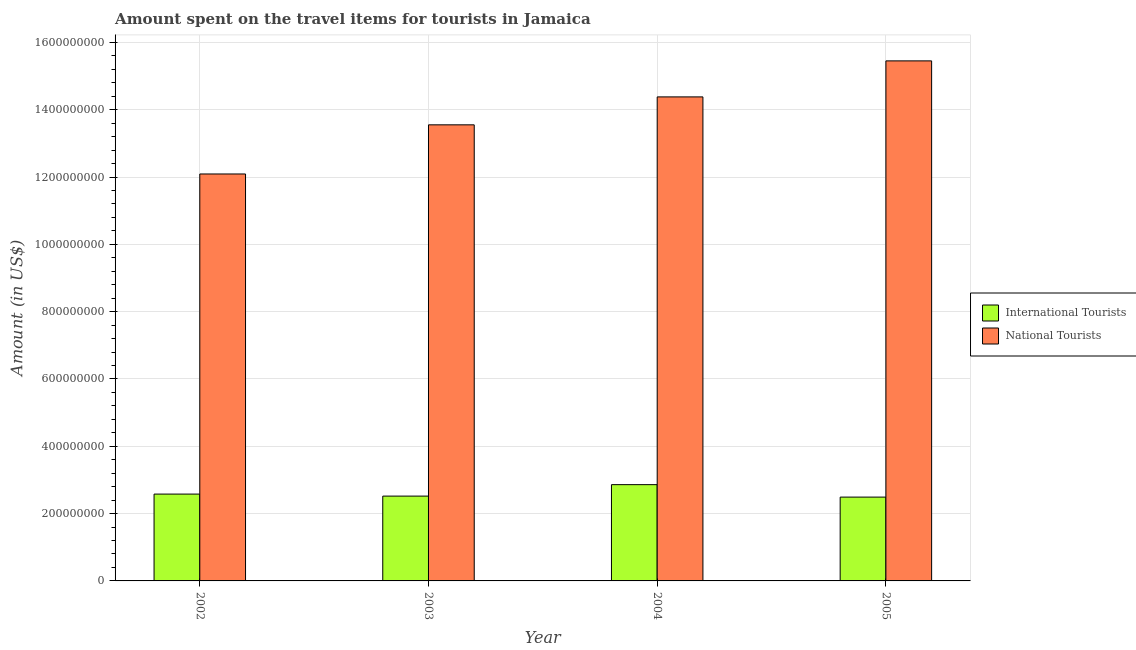How many different coloured bars are there?
Make the answer very short. 2. Are the number of bars on each tick of the X-axis equal?
Provide a short and direct response. Yes. How many bars are there on the 2nd tick from the right?
Ensure brevity in your answer.  2. What is the label of the 1st group of bars from the left?
Give a very brief answer. 2002. In how many cases, is the number of bars for a given year not equal to the number of legend labels?
Your response must be concise. 0. What is the amount spent on travel items of international tourists in 2003?
Offer a terse response. 2.52e+08. Across all years, what is the maximum amount spent on travel items of international tourists?
Provide a short and direct response. 2.86e+08. Across all years, what is the minimum amount spent on travel items of national tourists?
Offer a terse response. 1.21e+09. In which year was the amount spent on travel items of international tourists maximum?
Ensure brevity in your answer.  2004. What is the total amount spent on travel items of international tourists in the graph?
Keep it short and to the point. 1.04e+09. What is the difference between the amount spent on travel items of international tourists in 2002 and that in 2005?
Make the answer very short. 9.00e+06. What is the difference between the amount spent on travel items of international tourists in 2005 and the amount spent on travel items of national tourists in 2004?
Provide a short and direct response. -3.70e+07. What is the average amount spent on travel items of national tourists per year?
Offer a terse response. 1.39e+09. What is the ratio of the amount spent on travel items of international tourists in 2002 to that in 2005?
Provide a short and direct response. 1.04. What is the difference between the highest and the second highest amount spent on travel items of national tourists?
Your answer should be compact. 1.07e+08. What is the difference between the highest and the lowest amount spent on travel items of international tourists?
Your response must be concise. 3.70e+07. In how many years, is the amount spent on travel items of national tourists greater than the average amount spent on travel items of national tourists taken over all years?
Your response must be concise. 2. Is the sum of the amount spent on travel items of national tourists in 2003 and 2004 greater than the maximum amount spent on travel items of international tourists across all years?
Your response must be concise. Yes. What does the 1st bar from the left in 2005 represents?
Your response must be concise. International Tourists. What does the 1st bar from the right in 2003 represents?
Keep it short and to the point. National Tourists. How many bars are there?
Provide a succinct answer. 8. Are all the bars in the graph horizontal?
Offer a terse response. No. What is the difference between two consecutive major ticks on the Y-axis?
Give a very brief answer. 2.00e+08. Are the values on the major ticks of Y-axis written in scientific E-notation?
Ensure brevity in your answer.  No. Where does the legend appear in the graph?
Provide a succinct answer. Center right. How many legend labels are there?
Offer a terse response. 2. What is the title of the graph?
Ensure brevity in your answer.  Amount spent on the travel items for tourists in Jamaica. Does "Travel services" appear as one of the legend labels in the graph?
Make the answer very short. No. What is the label or title of the Y-axis?
Provide a succinct answer. Amount (in US$). What is the Amount (in US$) of International Tourists in 2002?
Make the answer very short. 2.58e+08. What is the Amount (in US$) of National Tourists in 2002?
Ensure brevity in your answer.  1.21e+09. What is the Amount (in US$) of International Tourists in 2003?
Give a very brief answer. 2.52e+08. What is the Amount (in US$) in National Tourists in 2003?
Give a very brief answer. 1.36e+09. What is the Amount (in US$) in International Tourists in 2004?
Give a very brief answer. 2.86e+08. What is the Amount (in US$) in National Tourists in 2004?
Your response must be concise. 1.44e+09. What is the Amount (in US$) in International Tourists in 2005?
Make the answer very short. 2.49e+08. What is the Amount (in US$) in National Tourists in 2005?
Offer a very short reply. 1.54e+09. Across all years, what is the maximum Amount (in US$) of International Tourists?
Keep it short and to the point. 2.86e+08. Across all years, what is the maximum Amount (in US$) of National Tourists?
Your response must be concise. 1.54e+09. Across all years, what is the minimum Amount (in US$) of International Tourists?
Ensure brevity in your answer.  2.49e+08. Across all years, what is the minimum Amount (in US$) of National Tourists?
Give a very brief answer. 1.21e+09. What is the total Amount (in US$) of International Tourists in the graph?
Make the answer very short. 1.04e+09. What is the total Amount (in US$) of National Tourists in the graph?
Provide a short and direct response. 5.55e+09. What is the difference between the Amount (in US$) in International Tourists in 2002 and that in 2003?
Offer a terse response. 6.00e+06. What is the difference between the Amount (in US$) of National Tourists in 2002 and that in 2003?
Your response must be concise. -1.46e+08. What is the difference between the Amount (in US$) in International Tourists in 2002 and that in 2004?
Your answer should be compact. -2.80e+07. What is the difference between the Amount (in US$) of National Tourists in 2002 and that in 2004?
Provide a short and direct response. -2.29e+08. What is the difference between the Amount (in US$) of International Tourists in 2002 and that in 2005?
Provide a succinct answer. 9.00e+06. What is the difference between the Amount (in US$) in National Tourists in 2002 and that in 2005?
Your response must be concise. -3.36e+08. What is the difference between the Amount (in US$) of International Tourists in 2003 and that in 2004?
Offer a terse response. -3.40e+07. What is the difference between the Amount (in US$) in National Tourists in 2003 and that in 2004?
Your answer should be very brief. -8.30e+07. What is the difference between the Amount (in US$) of International Tourists in 2003 and that in 2005?
Offer a terse response. 3.00e+06. What is the difference between the Amount (in US$) in National Tourists in 2003 and that in 2005?
Offer a very short reply. -1.90e+08. What is the difference between the Amount (in US$) in International Tourists in 2004 and that in 2005?
Ensure brevity in your answer.  3.70e+07. What is the difference between the Amount (in US$) of National Tourists in 2004 and that in 2005?
Offer a terse response. -1.07e+08. What is the difference between the Amount (in US$) of International Tourists in 2002 and the Amount (in US$) of National Tourists in 2003?
Your response must be concise. -1.10e+09. What is the difference between the Amount (in US$) in International Tourists in 2002 and the Amount (in US$) in National Tourists in 2004?
Make the answer very short. -1.18e+09. What is the difference between the Amount (in US$) in International Tourists in 2002 and the Amount (in US$) in National Tourists in 2005?
Offer a terse response. -1.29e+09. What is the difference between the Amount (in US$) of International Tourists in 2003 and the Amount (in US$) of National Tourists in 2004?
Provide a succinct answer. -1.19e+09. What is the difference between the Amount (in US$) in International Tourists in 2003 and the Amount (in US$) in National Tourists in 2005?
Give a very brief answer. -1.29e+09. What is the difference between the Amount (in US$) of International Tourists in 2004 and the Amount (in US$) of National Tourists in 2005?
Ensure brevity in your answer.  -1.26e+09. What is the average Amount (in US$) of International Tourists per year?
Provide a succinct answer. 2.61e+08. What is the average Amount (in US$) in National Tourists per year?
Provide a short and direct response. 1.39e+09. In the year 2002, what is the difference between the Amount (in US$) of International Tourists and Amount (in US$) of National Tourists?
Your answer should be compact. -9.51e+08. In the year 2003, what is the difference between the Amount (in US$) of International Tourists and Amount (in US$) of National Tourists?
Your answer should be compact. -1.10e+09. In the year 2004, what is the difference between the Amount (in US$) in International Tourists and Amount (in US$) in National Tourists?
Your answer should be compact. -1.15e+09. In the year 2005, what is the difference between the Amount (in US$) in International Tourists and Amount (in US$) in National Tourists?
Give a very brief answer. -1.30e+09. What is the ratio of the Amount (in US$) of International Tourists in 2002 to that in 2003?
Your answer should be very brief. 1.02. What is the ratio of the Amount (in US$) of National Tourists in 2002 to that in 2003?
Your answer should be compact. 0.89. What is the ratio of the Amount (in US$) of International Tourists in 2002 to that in 2004?
Make the answer very short. 0.9. What is the ratio of the Amount (in US$) of National Tourists in 2002 to that in 2004?
Your answer should be compact. 0.84. What is the ratio of the Amount (in US$) of International Tourists in 2002 to that in 2005?
Offer a terse response. 1.04. What is the ratio of the Amount (in US$) in National Tourists in 2002 to that in 2005?
Give a very brief answer. 0.78. What is the ratio of the Amount (in US$) in International Tourists in 2003 to that in 2004?
Offer a very short reply. 0.88. What is the ratio of the Amount (in US$) of National Tourists in 2003 to that in 2004?
Offer a terse response. 0.94. What is the ratio of the Amount (in US$) in National Tourists in 2003 to that in 2005?
Keep it short and to the point. 0.88. What is the ratio of the Amount (in US$) of International Tourists in 2004 to that in 2005?
Your answer should be compact. 1.15. What is the ratio of the Amount (in US$) in National Tourists in 2004 to that in 2005?
Keep it short and to the point. 0.93. What is the difference between the highest and the second highest Amount (in US$) of International Tourists?
Offer a very short reply. 2.80e+07. What is the difference between the highest and the second highest Amount (in US$) of National Tourists?
Your response must be concise. 1.07e+08. What is the difference between the highest and the lowest Amount (in US$) in International Tourists?
Make the answer very short. 3.70e+07. What is the difference between the highest and the lowest Amount (in US$) of National Tourists?
Give a very brief answer. 3.36e+08. 